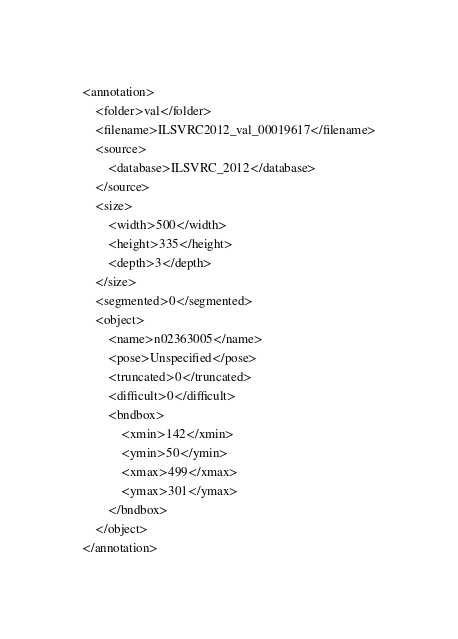Convert code to text. <code><loc_0><loc_0><loc_500><loc_500><_XML_><annotation>
	<folder>val</folder>
	<filename>ILSVRC2012_val_00019617</filename>
	<source>
		<database>ILSVRC_2012</database>
	</source>
	<size>
		<width>500</width>
		<height>335</height>
		<depth>3</depth>
	</size>
	<segmented>0</segmented>
	<object>
		<name>n02363005</name>
		<pose>Unspecified</pose>
		<truncated>0</truncated>
		<difficult>0</difficult>
		<bndbox>
			<xmin>142</xmin>
			<ymin>50</ymin>
			<xmax>499</xmax>
			<ymax>301</ymax>
		</bndbox>
	</object>
</annotation></code> 